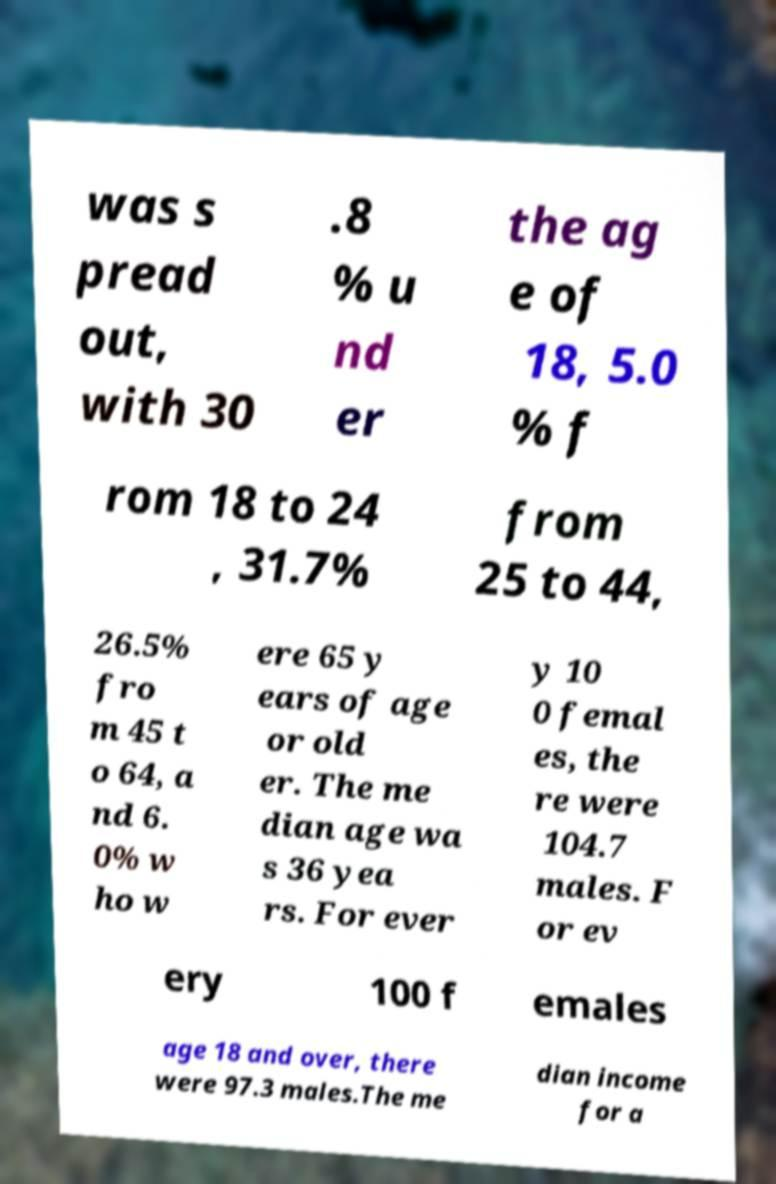Could you extract and type out the text from this image? was s pread out, with 30 .8 % u nd er the ag e of 18, 5.0 % f rom 18 to 24 , 31.7% from 25 to 44, 26.5% fro m 45 t o 64, a nd 6. 0% w ho w ere 65 y ears of age or old er. The me dian age wa s 36 yea rs. For ever y 10 0 femal es, the re were 104.7 males. F or ev ery 100 f emales age 18 and over, there were 97.3 males.The me dian income for a 